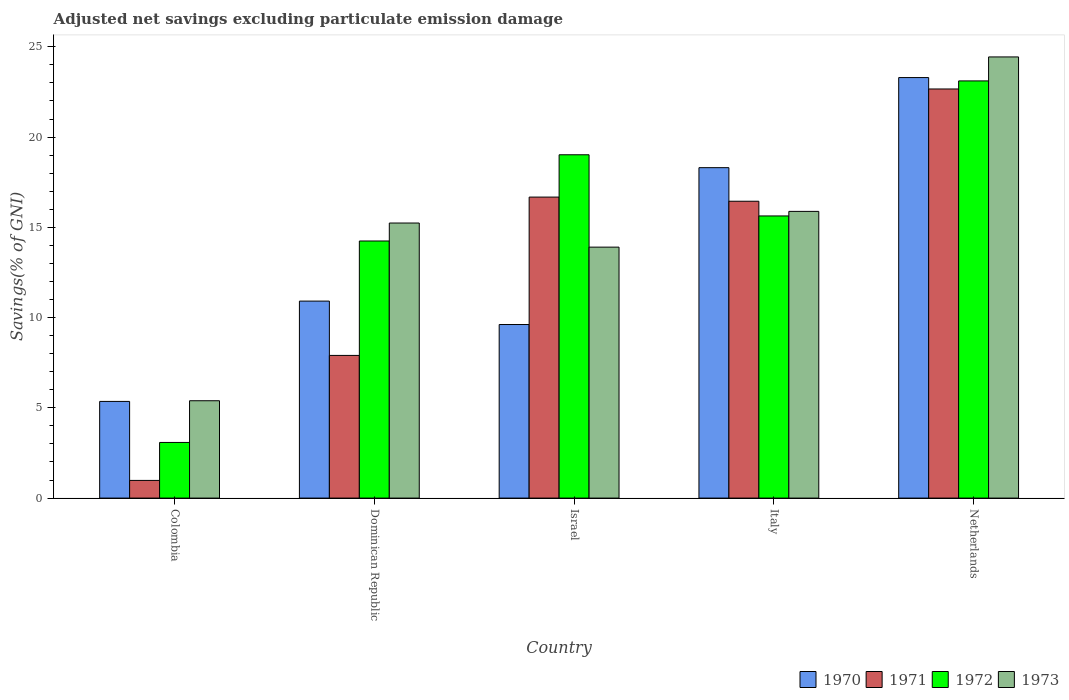How many groups of bars are there?
Your answer should be very brief. 5. Are the number of bars on each tick of the X-axis equal?
Make the answer very short. Yes. How many bars are there on the 4th tick from the left?
Ensure brevity in your answer.  4. How many bars are there on the 4th tick from the right?
Give a very brief answer. 4. What is the label of the 2nd group of bars from the left?
Offer a very short reply. Dominican Republic. In how many cases, is the number of bars for a given country not equal to the number of legend labels?
Give a very brief answer. 0. What is the adjusted net savings in 1972 in Israel?
Your answer should be very brief. 19.02. Across all countries, what is the maximum adjusted net savings in 1973?
Your answer should be compact. 24.44. Across all countries, what is the minimum adjusted net savings in 1970?
Make the answer very short. 5.36. In which country was the adjusted net savings in 1970 maximum?
Your answer should be very brief. Netherlands. What is the total adjusted net savings in 1972 in the graph?
Offer a terse response. 75.08. What is the difference between the adjusted net savings in 1973 in Dominican Republic and that in Italy?
Offer a very short reply. -0.64. What is the difference between the adjusted net savings in 1971 in Israel and the adjusted net savings in 1972 in Italy?
Give a very brief answer. 1.04. What is the average adjusted net savings in 1970 per country?
Your response must be concise. 13.5. What is the difference between the adjusted net savings of/in 1973 and adjusted net savings of/in 1971 in Colombia?
Make the answer very short. 4.41. What is the ratio of the adjusted net savings in 1970 in Dominican Republic to that in Netherlands?
Your answer should be compact. 0.47. Is the difference between the adjusted net savings in 1973 in Colombia and Netherlands greater than the difference between the adjusted net savings in 1971 in Colombia and Netherlands?
Give a very brief answer. Yes. What is the difference between the highest and the second highest adjusted net savings in 1972?
Your response must be concise. 3.39. What is the difference between the highest and the lowest adjusted net savings in 1972?
Ensure brevity in your answer.  20.03. In how many countries, is the adjusted net savings in 1971 greater than the average adjusted net savings in 1971 taken over all countries?
Your answer should be very brief. 3. Is it the case that in every country, the sum of the adjusted net savings in 1972 and adjusted net savings in 1971 is greater than the adjusted net savings in 1970?
Keep it short and to the point. No. How many bars are there?
Provide a succinct answer. 20. How many countries are there in the graph?
Give a very brief answer. 5. Are the values on the major ticks of Y-axis written in scientific E-notation?
Provide a short and direct response. No. Does the graph contain any zero values?
Provide a succinct answer. No. Does the graph contain grids?
Your response must be concise. No. Where does the legend appear in the graph?
Offer a terse response. Bottom right. How many legend labels are there?
Your response must be concise. 4. What is the title of the graph?
Your answer should be very brief. Adjusted net savings excluding particulate emission damage. Does "2001" appear as one of the legend labels in the graph?
Offer a very short reply. No. What is the label or title of the Y-axis?
Give a very brief answer. Savings(% of GNI). What is the Savings(% of GNI) of 1970 in Colombia?
Your response must be concise. 5.36. What is the Savings(% of GNI) in 1971 in Colombia?
Your answer should be compact. 0.98. What is the Savings(% of GNI) of 1972 in Colombia?
Give a very brief answer. 3.08. What is the Savings(% of GNI) in 1973 in Colombia?
Provide a succinct answer. 5.39. What is the Savings(% of GNI) of 1970 in Dominican Republic?
Ensure brevity in your answer.  10.91. What is the Savings(% of GNI) in 1971 in Dominican Republic?
Provide a succinct answer. 7.9. What is the Savings(% of GNI) of 1972 in Dominican Republic?
Keep it short and to the point. 14.24. What is the Savings(% of GNI) in 1973 in Dominican Republic?
Offer a very short reply. 15.24. What is the Savings(% of GNI) in 1970 in Israel?
Provide a succinct answer. 9.61. What is the Savings(% of GNI) in 1971 in Israel?
Your answer should be very brief. 16.67. What is the Savings(% of GNI) in 1972 in Israel?
Offer a terse response. 19.02. What is the Savings(% of GNI) of 1973 in Israel?
Ensure brevity in your answer.  13.9. What is the Savings(% of GNI) of 1970 in Italy?
Your answer should be compact. 18.3. What is the Savings(% of GNI) of 1971 in Italy?
Keep it short and to the point. 16.44. What is the Savings(% of GNI) of 1972 in Italy?
Provide a succinct answer. 15.63. What is the Savings(% of GNI) in 1973 in Italy?
Keep it short and to the point. 15.88. What is the Savings(% of GNI) of 1970 in Netherlands?
Your response must be concise. 23.3. What is the Savings(% of GNI) in 1971 in Netherlands?
Your response must be concise. 22.66. What is the Savings(% of GNI) in 1972 in Netherlands?
Your answer should be compact. 23.11. What is the Savings(% of GNI) in 1973 in Netherlands?
Offer a terse response. 24.44. Across all countries, what is the maximum Savings(% of GNI) of 1970?
Offer a very short reply. 23.3. Across all countries, what is the maximum Savings(% of GNI) in 1971?
Your answer should be very brief. 22.66. Across all countries, what is the maximum Savings(% of GNI) of 1972?
Make the answer very short. 23.11. Across all countries, what is the maximum Savings(% of GNI) of 1973?
Provide a short and direct response. 24.44. Across all countries, what is the minimum Savings(% of GNI) of 1970?
Your answer should be very brief. 5.36. Across all countries, what is the minimum Savings(% of GNI) in 1971?
Your answer should be very brief. 0.98. Across all countries, what is the minimum Savings(% of GNI) in 1972?
Your answer should be very brief. 3.08. Across all countries, what is the minimum Savings(% of GNI) of 1973?
Ensure brevity in your answer.  5.39. What is the total Savings(% of GNI) in 1970 in the graph?
Your answer should be very brief. 67.48. What is the total Savings(% of GNI) of 1971 in the graph?
Provide a short and direct response. 64.66. What is the total Savings(% of GNI) in 1972 in the graph?
Offer a terse response. 75.08. What is the total Savings(% of GNI) in 1973 in the graph?
Your answer should be very brief. 74.85. What is the difference between the Savings(% of GNI) of 1970 in Colombia and that in Dominican Republic?
Provide a short and direct response. -5.56. What is the difference between the Savings(% of GNI) in 1971 in Colombia and that in Dominican Republic?
Keep it short and to the point. -6.92. What is the difference between the Savings(% of GNI) in 1972 in Colombia and that in Dominican Republic?
Provide a short and direct response. -11.16. What is the difference between the Savings(% of GNI) of 1973 in Colombia and that in Dominican Republic?
Keep it short and to the point. -9.85. What is the difference between the Savings(% of GNI) of 1970 in Colombia and that in Israel?
Make the answer very short. -4.26. What is the difference between the Savings(% of GNI) of 1971 in Colombia and that in Israel?
Keep it short and to the point. -15.7. What is the difference between the Savings(% of GNI) in 1972 in Colombia and that in Israel?
Keep it short and to the point. -15.94. What is the difference between the Savings(% of GNI) in 1973 in Colombia and that in Israel?
Ensure brevity in your answer.  -8.51. What is the difference between the Savings(% of GNI) of 1970 in Colombia and that in Italy?
Provide a succinct answer. -12.95. What is the difference between the Savings(% of GNI) in 1971 in Colombia and that in Italy?
Provide a succinct answer. -15.46. What is the difference between the Savings(% of GNI) in 1972 in Colombia and that in Italy?
Keep it short and to the point. -12.55. What is the difference between the Savings(% of GNI) in 1973 in Colombia and that in Italy?
Your answer should be compact. -10.49. What is the difference between the Savings(% of GNI) of 1970 in Colombia and that in Netherlands?
Offer a terse response. -17.94. What is the difference between the Savings(% of GNI) in 1971 in Colombia and that in Netherlands?
Offer a very short reply. -21.68. What is the difference between the Savings(% of GNI) in 1972 in Colombia and that in Netherlands?
Ensure brevity in your answer.  -20.03. What is the difference between the Savings(% of GNI) in 1973 in Colombia and that in Netherlands?
Offer a terse response. -19.05. What is the difference between the Savings(% of GNI) of 1970 in Dominican Republic and that in Israel?
Your response must be concise. 1.3. What is the difference between the Savings(% of GNI) in 1971 in Dominican Republic and that in Israel?
Your response must be concise. -8.77. What is the difference between the Savings(% of GNI) of 1972 in Dominican Republic and that in Israel?
Your answer should be compact. -4.78. What is the difference between the Savings(% of GNI) of 1973 in Dominican Republic and that in Israel?
Make the answer very short. 1.34. What is the difference between the Savings(% of GNI) of 1970 in Dominican Republic and that in Italy?
Make the answer very short. -7.39. What is the difference between the Savings(% of GNI) of 1971 in Dominican Republic and that in Italy?
Offer a terse response. -8.54. What is the difference between the Savings(% of GNI) in 1972 in Dominican Republic and that in Italy?
Your answer should be compact. -1.39. What is the difference between the Savings(% of GNI) of 1973 in Dominican Republic and that in Italy?
Provide a succinct answer. -0.65. What is the difference between the Savings(% of GNI) in 1970 in Dominican Republic and that in Netherlands?
Offer a terse response. -12.38. What is the difference between the Savings(% of GNI) in 1971 in Dominican Republic and that in Netherlands?
Offer a terse response. -14.76. What is the difference between the Savings(% of GNI) in 1972 in Dominican Republic and that in Netherlands?
Make the answer very short. -8.87. What is the difference between the Savings(% of GNI) of 1973 in Dominican Republic and that in Netherlands?
Your answer should be compact. -9.2. What is the difference between the Savings(% of GNI) in 1970 in Israel and that in Italy?
Your answer should be compact. -8.69. What is the difference between the Savings(% of GNI) of 1971 in Israel and that in Italy?
Your answer should be very brief. 0.23. What is the difference between the Savings(% of GNI) in 1972 in Israel and that in Italy?
Provide a short and direct response. 3.39. What is the difference between the Savings(% of GNI) of 1973 in Israel and that in Italy?
Keep it short and to the point. -1.98. What is the difference between the Savings(% of GNI) of 1970 in Israel and that in Netherlands?
Ensure brevity in your answer.  -13.68. What is the difference between the Savings(% of GNI) in 1971 in Israel and that in Netherlands?
Give a very brief answer. -5.99. What is the difference between the Savings(% of GNI) of 1972 in Israel and that in Netherlands?
Offer a very short reply. -4.09. What is the difference between the Savings(% of GNI) of 1973 in Israel and that in Netherlands?
Keep it short and to the point. -10.54. What is the difference between the Savings(% of GNI) of 1970 in Italy and that in Netherlands?
Your answer should be compact. -4.99. What is the difference between the Savings(% of GNI) in 1971 in Italy and that in Netherlands?
Your answer should be very brief. -6.22. What is the difference between the Savings(% of GNI) in 1972 in Italy and that in Netherlands?
Your response must be concise. -7.48. What is the difference between the Savings(% of GNI) in 1973 in Italy and that in Netherlands?
Your response must be concise. -8.56. What is the difference between the Savings(% of GNI) in 1970 in Colombia and the Savings(% of GNI) in 1971 in Dominican Republic?
Provide a succinct answer. -2.55. What is the difference between the Savings(% of GNI) of 1970 in Colombia and the Savings(% of GNI) of 1972 in Dominican Republic?
Your answer should be compact. -8.89. What is the difference between the Savings(% of GNI) of 1970 in Colombia and the Savings(% of GNI) of 1973 in Dominican Republic?
Keep it short and to the point. -9.88. What is the difference between the Savings(% of GNI) of 1971 in Colombia and the Savings(% of GNI) of 1972 in Dominican Republic?
Your response must be concise. -13.26. What is the difference between the Savings(% of GNI) in 1971 in Colombia and the Savings(% of GNI) in 1973 in Dominican Republic?
Provide a succinct answer. -14.26. What is the difference between the Savings(% of GNI) in 1972 in Colombia and the Savings(% of GNI) in 1973 in Dominican Republic?
Offer a terse response. -12.15. What is the difference between the Savings(% of GNI) of 1970 in Colombia and the Savings(% of GNI) of 1971 in Israel?
Provide a short and direct response. -11.32. What is the difference between the Savings(% of GNI) of 1970 in Colombia and the Savings(% of GNI) of 1972 in Israel?
Offer a very short reply. -13.66. What is the difference between the Savings(% of GNI) of 1970 in Colombia and the Savings(% of GNI) of 1973 in Israel?
Your answer should be compact. -8.55. What is the difference between the Savings(% of GNI) in 1971 in Colombia and the Savings(% of GNI) in 1972 in Israel?
Your answer should be compact. -18.04. What is the difference between the Savings(% of GNI) in 1971 in Colombia and the Savings(% of GNI) in 1973 in Israel?
Keep it short and to the point. -12.92. What is the difference between the Savings(% of GNI) of 1972 in Colombia and the Savings(% of GNI) of 1973 in Israel?
Your response must be concise. -10.82. What is the difference between the Savings(% of GNI) of 1970 in Colombia and the Savings(% of GNI) of 1971 in Italy?
Offer a terse response. -11.09. What is the difference between the Savings(% of GNI) in 1970 in Colombia and the Savings(% of GNI) in 1972 in Italy?
Provide a succinct answer. -10.27. What is the difference between the Savings(% of GNI) of 1970 in Colombia and the Savings(% of GNI) of 1973 in Italy?
Offer a terse response. -10.53. What is the difference between the Savings(% of GNI) of 1971 in Colombia and the Savings(% of GNI) of 1972 in Italy?
Ensure brevity in your answer.  -14.65. What is the difference between the Savings(% of GNI) in 1971 in Colombia and the Savings(% of GNI) in 1973 in Italy?
Your answer should be compact. -14.9. What is the difference between the Savings(% of GNI) of 1972 in Colombia and the Savings(% of GNI) of 1973 in Italy?
Your response must be concise. -12.8. What is the difference between the Savings(% of GNI) of 1970 in Colombia and the Savings(% of GNI) of 1971 in Netherlands?
Offer a very short reply. -17.31. What is the difference between the Savings(% of GNI) in 1970 in Colombia and the Savings(% of GNI) in 1972 in Netherlands?
Provide a short and direct response. -17.75. What is the difference between the Savings(% of GNI) in 1970 in Colombia and the Savings(% of GNI) in 1973 in Netherlands?
Ensure brevity in your answer.  -19.08. What is the difference between the Savings(% of GNI) in 1971 in Colombia and the Savings(% of GNI) in 1972 in Netherlands?
Offer a very short reply. -22.13. What is the difference between the Savings(% of GNI) in 1971 in Colombia and the Savings(% of GNI) in 1973 in Netherlands?
Provide a short and direct response. -23.46. What is the difference between the Savings(% of GNI) of 1972 in Colombia and the Savings(% of GNI) of 1973 in Netherlands?
Ensure brevity in your answer.  -21.36. What is the difference between the Savings(% of GNI) of 1970 in Dominican Republic and the Savings(% of GNI) of 1971 in Israel?
Your answer should be very brief. -5.76. What is the difference between the Savings(% of GNI) in 1970 in Dominican Republic and the Savings(% of GNI) in 1972 in Israel?
Your answer should be very brief. -8.11. What is the difference between the Savings(% of GNI) in 1970 in Dominican Republic and the Savings(% of GNI) in 1973 in Israel?
Give a very brief answer. -2.99. What is the difference between the Savings(% of GNI) in 1971 in Dominican Republic and the Savings(% of GNI) in 1972 in Israel?
Make the answer very short. -11.11. What is the difference between the Savings(% of GNI) of 1971 in Dominican Republic and the Savings(% of GNI) of 1973 in Israel?
Your answer should be compact. -6. What is the difference between the Savings(% of GNI) of 1972 in Dominican Republic and the Savings(% of GNI) of 1973 in Israel?
Your answer should be compact. 0.34. What is the difference between the Savings(% of GNI) in 1970 in Dominican Republic and the Savings(% of GNI) in 1971 in Italy?
Provide a succinct answer. -5.53. What is the difference between the Savings(% of GNI) of 1970 in Dominican Republic and the Savings(% of GNI) of 1972 in Italy?
Provide a short and direct response. -4.72. What is the difference between the Savings(% of GNI) in 1970 in Dominican Republic and the Savings(% of GNI) in 1973 in Italy?
Keep it short and to the point. -4.97. What is the difference between the Savings(% of GNI) of 1971 in Dominican Republic and the Savings(% of GNI) of 1972 in Italy?
Your answer should be compact. -7.73. What is the difference between the Savings(% of GNI) of 1971 in Dominican Republic and the Savings(% of GNI) of 1973 in Italy?
Make the answer very short. -7.98. What is the difference between the Savings(% of GNI) of 1972 in Dominican Republic and the Savings(% of GNI) of 1973 in Italy?
Your answer should be very brief. -1.64. What is the difference between the Savings(% of GNI) in 1970 in Dominican Republic and the Savings(% of GNI) in 1971 in Netherlands?
Keep it short and to the point. -11.75. What is the difference between the Savings(% of GNI) of 1970 in Dominican Republic and the Savings(% of GNI) of 1972 in Netherlands?
Offer a very short reply. -12.2. What is the difference between the Savings(% of GNI) of 1970 in Dominican Republic and the Savings(% of GNI) of 1973 in Netherlands?
Your answer should be very brief. -13.53. What is the difference between the Savings(% of GNI) in 1971 in Dominican Republic and the Savings(% of GNI) in 1972 in Netherlands?
Keep it short and to the point. -15.21. What is the difference between the Savings(% of GNI) of 1971 in Dominican Republic and the Savings(% of GNI) of 1973 in Netherlands?
Make the answer very short. -16.53. What is the difference between the Savings(% of GNI) of 1972 in Dominican Republic and the Savings(% of GNI) of 1973 in Netherlands?
Provide a short and direct response. -10.2. What is the difference between the Savings(% of GNI) of 1970 in Israel and the Savings(% of GNI) of 1971 in Italy?
Keep it short and to the point. -6.83. What is the difference between the Savings(% of GNI) in 1970 in Israel and the Savings(% of GNI) in 1972 in Italy?
Provide a succinct answer. -6.02. What is the difference between the Savings(% of GNI) in 1970 in Israel and the Savings(% of GNI) in 1973 in Italy?
Offer a terse response. -6.27. What is the difference between the Savings(% of GNI) of 1971 in Israel and the Savings(% of GNI) of 1972 in Italy?
Ensure brevity in your answer.  1.04. What is the difference between the Savings(% of GNI) of 1971 in Israel and the Savings(% of GNI) of 1973 in Italy?
Offer a terse response. 0.79. What is the difference between the Savings(% of GNI) of 1972 in Israel and the Savings(% of GNI) of 1973 in Italy?
Offer a terse response. 3.14. What is the difference between the Savings(% of GNI) in 1970 in Israel and the Savings(% of GNI) in 1971 in Netherlands?
Ensure brevity in your answer.  -13.05. What is the difference between the Savings(% of GNI) of 1970 in Israel and the Savings(% of GNI) of 1972 in Netherlands?
Offer a terse response. -13.49. What is the difference between the Savings(% of GNI) in 1970 in Israel and the Savings(% of GNI) in 1973 in Netherlands?
Ensure brevity in your answer.  -14.82. What is the difference between the Savings(% of GNI) of 1971 in Israel and the Savings(% of GNI) of 1972 in Netherlands?
Ensure brevity in your answer.  -6.44. What is the difference between the Savings(% of GNI) of 1971 in Israel and the Savings(% of GNI) of 1973 in Netherlands?
Your response must be concise. -7.76. What is the difference between the Savings(% of GNI) in 1972 in Israel and the Savings(% of GNI) in 1973 in Netherlands?
Provide a short and direct response. -5.42. What is the difference between the Savings(% of GNI) in 1970 in Italy and the Savings(% of GNI) in 1971 in Netherlands?
Your answer should be very brief. -4.36. What is the difference between the Savings(% of GNI) of 1970 in Italy and the Savings(% of GNI) of 1972 in Netherlands?
Keep it short and to the point. -4.81. What is the difference between the Savings(% of GNI) in 1970 in Italy and the Savings(% of GNI) in 1973 in Netherlands?
Keep it short and to the point. -6.13. What is the difference between the Savings(% of GNI) of 1971 in Italy and the Savings(% of GNI) of 1972 in Netherlands?
Offer a terse response. -6.67. What is the difference between the Savings(% of GNI) of 1971 in Italy and the Savings(% of GNI) of 1973 in Netherlands?
Your answer should be very brief. -7.99. What is the difference between the Savings(% of GNI) in 1972 in Italy and the Savings(% of GNI) in 1973 in Netherlands?
Your answer should be very brief. -8.81. What is the average Savings(% of GNI) of 1970 per country?
Make the answer very short. 13.5. What is the average Savings(% of GNI) in 1971 per country?
Provide a short and direct response. 12.93. What is the average Savings(% of GNI) in 1972 per country?
Your answer should be compact. 15.02. What is the average Savings(% of GNI) in 1973 per country?
Offer a terse response. 14.97. What is the difference between the Savings(% of GNI) in 1970 and Savings(% of GNI) in 1971 in Colombia?
Provide a short and direct response. 4.38. What is the difference between the Savings(% of GNI) in 1970 and Savings(% of GNI) in 1972 in Colombia?
Provide a succinct answer. 2.27. What is the difference between the Savings(% of GNI) in 1970 and Savings(% of GNI) in 1973 in Colombia?
Provide a short and direct response. -0.04. What is the difference between the Savings(% of GNI) in 1971 and Savings(% of GNI) in 1972 in Colombia?
Give a very brief answer. -2.1. What is the difference between the Savings(% of GNI) of 1971 and Savings(% of GNI) of 1973 in Colombia?
Keep it short and to the point. -4.41. What is the difference between the Savings(% of GNI) of 1972 and Savings(% of GNI) of 1973 in Colombia?
Keep it short and to the point. -2.31. What is the difference between the Savings(% of GNI) of 1970 and Savings(% of GNI) of 1971 in Dominican Republic?
Offer a very short reply. 3.01. What is the difference between the Savings(% of GNI) in 1970 and Savings(% of GNI) in 1972 in Dominican Republic?
Make the answer very short. -3.33. What is the difference between the Savings(% of GNI) of 1970 and Savings(% of GNI) of 1973 in Dominican Republic?
Offer a terse response. -4.33. What is the difference between the Savings(% of GNI) in 1971 and Savings(% of GNI) in 1972 in Dominican Republic?
Provide a short and direct response. -6.34. What is the difference between the Savings(% of GNI) of 1971 and Savings(% of GNI) of 1973 in Dominican Republic?
Give a very brief answer. -7.33. What is the difference between the Savings(% of GNI) in 1972 and Savings(% of GNI) in 1973 in Dominican Republic?
Ensure brevity in your answer.  -1. What is the difference between the Savings(% of GNI) in 1970 and Savings(% of GNI) in 1971 in Israel?
Provide a short and direct response. -7.06. What is the difference between the Savings(% of GNI) in 1970 and Savings(% of GNI) in 1972 in Israel?
Keep it short and to the point. -9.4. What is the difference between the Savings(% of GNI) in 1970 and Savings(% of GNI) in 1973 in Israel?
Make the answer very short. -4.29. What is the difference between the Savings(% of GNI) of 1971 and Savings(% of GNI) of 1972 in Israel?
Your answer should be very brief. -2.34. What is the difference between the Savings(% of GNI) in 1971 and Savings(% of GNI) in 1973 in Israel?
Make the answer very short. 2.77. What is the difference between the Savings(% of GNI) of 1972 and Savings(% of GNI) of 1973 in Israel?
Your response must be concise. 5.12. What is the difference between the Savings(% of GNI) in 1970 and Savings(% of GNI) in 1971 in Italy?
Make the answer very short. 1.86. What is the difference between the Savings(% of GNI) of 1970 and Savings(% of GNI) of 1972 in Italy?
Give a very brief answer. 2.67. What is the difference between the Savings(% of GNI) of 1970 and Savings(% of GNI) of 1973 in Italy?
Offer a very short reply. 2.42. What is the difference between the Savings(% of GNI) of 1971 and Savings(% of GNI) of 1972 in Italy?
Your answer should be compact. 0.81. What is the difference between the Savings(% of GNI) of 1971 and Savings(% of GNI) of 1973 in Italy?
Offer a very short reply. 0.56. What is the difference between the Savings(% of GNI) of 1972 and Savings(% of GNI) of 1973 in Italy?
Provide a short and direct response. -0.25. What is the difference between the Savings(% of GNI) of 1970 and Savings(% of GNI) of 1971 in Netherlands?
Offer a terse response. 0.63. What is the difference between the Savings(% of GNI) in 1970 and Savings(% of GNI) in 1972 in Netherlands?
Offer a terse response. 0.19. What is the difference between the Savings(% of GNI) of 1970 and Savings(% of GNI) of 1973 in Netherlands?
Your answer should be very brief. -1.14. What is the difference between the Savings(% of GNI) of 1971 and Savings(% of GNI) of 1972 in Netherlands?
Provide a succinct answer. -0.45. What is the difference between the Savings(% of GNI) in 1971 and Savings(% of GNI) in 1973 in Netherlands?
Your response must be concise. -1.77. What is the difference between the Savings(% of GNI) in 1972 and Savings(% of GNI) in 1973 in Netherlands?
Your response must be concise. -1.33. What is the ratio of the Savings(% of GNI) in 1970 in Colombia to that in Dominican Republic?
Ensure brevity in your answer.  0.49. What is the ratio of the Savings(% of GNI) in 1971 in Colombia to that in Dominican Republic?
Your answer should be compact. 0.12. What is the ratio of the Savings(% of GNI) in 1972 in Colombia to that in Dominican Republic?
Provide a succinct answer. 0.22. What is the ratio of the Savings(% of GNI) of 1973 in Colombia to that in Dominican Republic?
Ensure brevity in your answer.  0.35. What is the ratio of the Savings(% of GNI) of 1970 in Colombia to that in Israel?
Provide a short and direct response. 0.56. What is the ratio of the Savings(% of GNI) in 1971 in Colombia to that in Israel?
Provide a short and direct response. 0.06. What is the ratio of the Savings(% of GNI) of 1972 in Colombia to that in Israel?
Your answer should be very brief. 0.16. What is the ratio of the Savings(% of GNI) in 1973 in Colombia to that in Israel?
Your answer should be very brief. 0.39. What is the ratio of the Savings(% of GNI) in 1970 in Colombia to that in Italy?
Provide a short and direct response. 0.29. What is the ratio of the Savings(% of GNI) of 1971 in Colombia to that in Italy?
Keep it short and to the point. 0.06. What is the ratio of the Savings(% of GNI) of 1972 in Colombia to that in Italy?
Give a very brief answer. 0.2. What is the ratio of the Savings(% of GNI) of 1973 in Colombia to that in Italy?
Offer a very short reply. 0.34. What is the ratio of the Savings(% of GNI) of 1970 in Colombia to that in Netherlands?
Your response must be concise. 0.23. What is the ratio of the Savings(% of GNI) of 1971 in Colombia to that in Netherlands?
Your response must be concise. 0.04. What is the ratio of the Savings(% of GNI) in 1972 in Colombia to that in Netherlands?
Offer a terse response. 0.13. What is the ratio of the Savings(% of GNI) of 1973 in Colombia to that in Netherlands?
Keep it short and to the point. 0.22. What is the ratio of the Savings(% of GNI) in 1970 in Dominican Republic to that in Israel?
Your answer should be very brief. 1.14. What is the ratio of the Savings(% of GNI) in 1971 in Dominican Republic to that in Israel?
Your answer should be compact. 0.47. What is the ratio of the Savings(% of GNI) in 1972 in Dominican Republic to that in Israel?
Give a very brief answer. 0.75. What is the ratio of the Savings(% of GNI) of 1973 in Dominican Republic to that in Israel?
Your response must be concise. 1.1. What is the ratio of the Savings(% of GNI) in 1970 in Dominican Republic to that in Italy?
Make the answer very short. 0.6. What is the ratio of the Savings(% of GNI) of 1971 in Dominican Republic to that in Italy?
Give a very brief answer. 0.48. What is the ratio of the Savings(% of GNI) of 1972 in Dominican Republic to that in Italy?
Make the answer very short. 0.91. What is the ratio of the Savings(% of GNI) of 1973 in Dominican Republic to that in Italy?
Offer a terse response. 0.96. What is the ratio of the Savings(% of GNI) in 1970 in Dominican Republic to that in Netherlands?
Keep it short and to the point. 0.47. What is the ratio of the Savings(% of GNI) of 1971 in Dominican Republic to that in Netherlands?
Your response must be concise. 0.35. What is the ratio of the Savings(% of GNI) in 1972 in Dominican Republic to that in Netherlands?
Provide a short and direct response. 0.62. What is the ratio of the Savings(% of GNI) in 1973 in Dominican Republic to that in Netherlands?
Provide a succinct answer. 0.62. What is the ratio of the Savings(% of GNI) of 1970 in Israel to that in Italy?
Offer a very short reply. 0.53. What is the ratio of the Savings(% of GNI) of 1971 in Israel to that in Italy?
Offer a terse response. 1.01. What is the ratio of the Savings(% of GNI) of 1972 in Israel to that in Italy?
Keep it short and to the point. 1.22. What is the ratio of the Savings(% of GNI) of 1973 in Israel to that in Italy?
Your answer should be compact. 0.88. What is the ratio of the Savings(% of GNI) in 1970 in Israel to that in Netherlands?
Your answer should be compact. 0.41. What is the ratio of the Savings(% of GNI) in 1971 in Israel to that in Netherlands?
Offer a terse response. 0.74. What is the ratio of the Savings(% of GNI) of 1972 in Israel to that in Netherlands?
Provide a succinct answer. 0.82. What is the ratio of the Savings(% of GNI) of 1973 in Israel to that in Netherlands?
Your answer should be very brief. 0.57. What is the ratio of the Savings(% of GNI) of 1970 in Italy to that in Netherlands?
Ensure brevity in your answer.  0.79. What is the ratio of the Savings(% of GNI) of 1971 in Italy to that in Netherlands?
Offer a very short reply. 0.73. What is the ratio of the Savings(% of GNI) in 1972 in Italy to that in Netherlands?
Your answer should be very brief. 0.68. What is the ratio of the Savings(% of GNI) of 1973 in Italy to that in Netherlands?
Provide a succinct answer. 0.65. What is the difference between the highest and the second highest Savings(% of GNI) of 1970?
Your answer should be very brief. 4.99. What is the difference between the highest and the second highest Savings(% of GNI) of 1971?
Ensure brevity in your answer.  5.99. What is the difference between the highest and the second highest Savings(% of GNI) in 1972?
Offer a very short reply. 4.09. What is the difference between the highest and the second highest Savings(% of GNI) in 1973?
Give a very brief answer. 8.56. What is the difference between the highest and the lowest Savings(% of GNI) in 1970?
Provide a succinct answer. 17.94. What is the difference between the highest and the lowest Savings(% of GNI) of 1971?
Your response must be concise. 21.68. What is the difference between the highest and the lowest Savings(% of GNI) of 1972?
Make the answer very short. 20.03. What is the difference between the highest and the lowest Savings(% of GNI) of 1973?
Give a very brief answer. 19.05. 